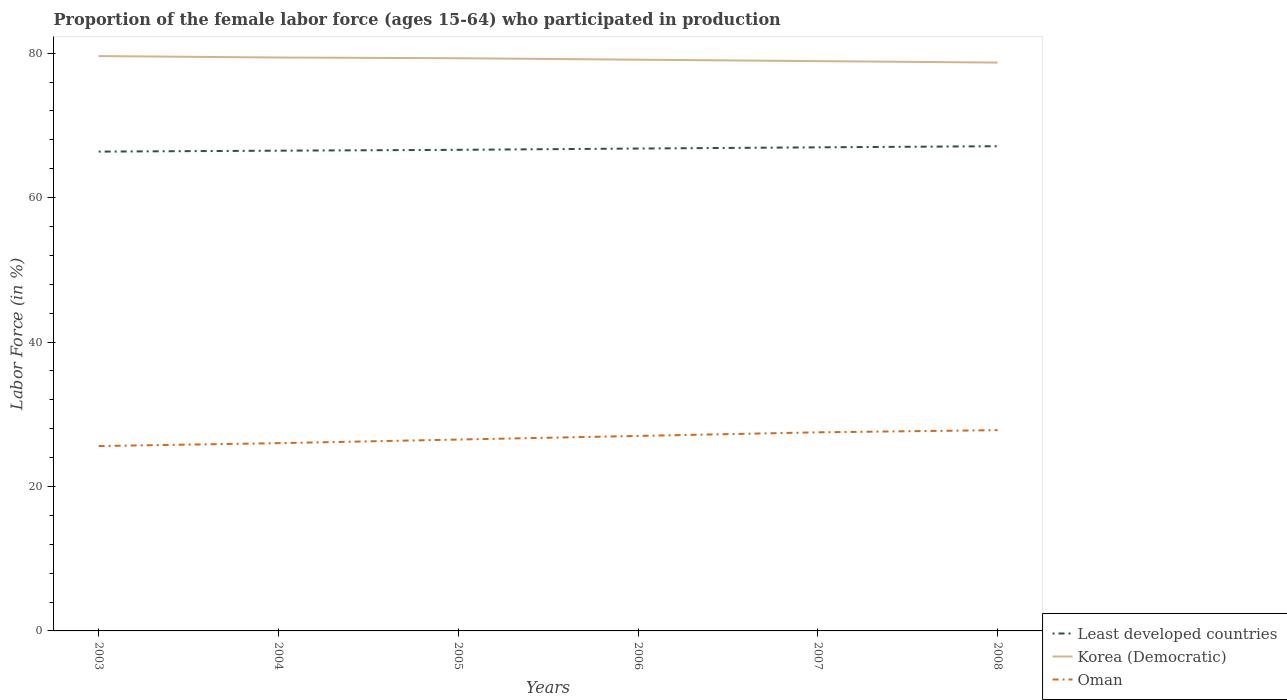How many different coloured lines are there?
Keep it short and to the point. 3. Does the line corresponding to Least developed countries intersect with the line corresponding to Oman?
Your answer should be very brief. No. Across all years, what is the maximum proportion of the female labor force who participated in production in Oman?
Give a very brief answer. 25.6. In which year was the proportion of the female labor force who participated in production in Least developed countries maximum?
Make the answer very short. 2003. What is the total proportion of the female labor force who participated in production in Korea (Democratic) in the graph?
Offer a terse response. 0.3. What is the difference between the highest and the second highest proportion of the female labor force who participated in production in Oman?
Your answer should be compact. 2.2. How many lines are there?
Your answer should be compact. 3. How many years are there in the graph?
Keep it short and to the point. 6. Does the graph contain any zero values?
Give a very brief answer. No. Does the graph contain grids?
Your answer should be very brief. No. What is the title of the graph?
Give a very brief answer. Proportion of the female labor force (ages 15-64) who participated in production. What is the label or title of the X-axis?
Offer a very short reply. Years. What is the label or title of the Y-axis?
Your answer should be very brief. Labor Force (in %). What is the Labor Force (in %) of Least developed countries in 2003?
Make the answer very short. 66.37. What is the Labor Force (in %) of Korea (Democratic) in 2003?
Offer a very short reply. 79.6. What is the Labor Force (in %) in Oman in 2003?
Provide a succinct answer. 25.6. What is the Labor Force (in %) of Least developed countries in 2004?
Your response must be concise. 66.5. What is the Labor Force (in %) of Korea (Democratic) in 2004?
Your response must be concise. 79.4. What is the Labor Force (in %) in Least developed countries in 2005?
Provide a short and direct response. 66.62. What is the Labor Force (in %) in Korea (Democratic) in 2005?
Offer a very short reply. 79.3. What is the Labor Force (in %) of Least developed countries in 2006?
Ensure brevity in your answer.  66.8. What is the Labor Force (in %) in Korea (Democratic) in 2006?
Provide a short and direct response. 79.1. What is the Labor Force (in %) of Least developed countries in 2007?
Provide a short and direct response. 66.96. What is the Labor Force (in %) of Korea (Democratic) in 2007?
Keep it short and to the point. 78.9. What is the Labor Force (in %) of Oman in 2007?
Ensure brevity in your answer.  27.5. What is the Labor Force (in %) of Least developed countries in 2008?
Offer a terse response. 67.12. What is the Labor Force (in %) in Korea (Democratic) in 2008?
Keep it short and to the point. 78.7. What is the Labor Force (in %) in Oman in 2008?
Ensure brevity in your answer.  27.8. Across all years, what is the maximum Labor Force (in %) of Least developed countries?
Offer a terse response. 67.12. Across all years, what is the maximum Labor Force (in %) in Korea (Democratic)?
Ensure brevity in your answer.  79.6. Across all years, what is the maximum Labor Force (in %) of Oman?
Keep it short and to the point. 27.8. Across all years, what is the minimum Labor Force (in %) of Least developed countries?
Provide a succinct answer. 66.37. Across all years, what is the minimum Labor Force (in %) in Korea (Democratic)?
Provide a succinct answer. 78.7. Across all years, what is the minimum Labor Force (in %) of Oman?
Keep it short and to the point. 25.6. What is the total Labor Force (in %) of Least developed countries in the graph?
Provide a succinct answer. 400.37. What is the total Labor Force (in %) in Korea (Democratic) in the graph?
Your answer should be compact. 475. What is the total Labor Force (in %) of Oman in the graph?
Keep it short and to the point. 160.4. What is the difference between the Labor Force (in %) of Least developed countries in 2003 and that in 2004?
Your response must be concise. -0.13. What is the difference between the Labor Force (in %) of Oman in 2003 and that in 2004?
Provide a short and direct response. -0.4. What is the difference between the Labor Force (in %) in Least developed countries in 2003 and that in 2005?
Keep it short and to the point. -0.25. What is the difference between the Labor Force (in %) of Korea (Democratic) in 2003 and that in 2005?
Your answer should be compact. 0.3. What is the difference between the Labor Force (in %) of Least developed countries in 2003 and that in 2006?
Give a very brief answer. -0.43. What is the difference between the Labor Force (in %) in Korea (Democratic) in 2003 and that in 2006?
Provide a succinct answer. 0.5. What is the difference between the Labor Force (in %) of Oman in 2003 and that in 2006?
Your answer should be very brief. -1.4. What is the difference between the Labor Force (in %) in Least developed countries in 2003 and that in 2007?
Provide a succinct answer. -0.59. What is the difference between the Labor Force (in %) of Least developed countries in 2003 and that in 2008?
Ensure brevity in your answer.  -0.75. What is the difference between the Labor Force (in %) of Oman in 2003 and that in 2008?
Provide a succinct answer. -2.2. What is the difference between the Labor Force (in %) in Least developed countries in 2004 and that in 2005?
Ensure brevity in your answer.  -0.12. What is the difference between the Labor Force (in %) of Korea (Democratic) in 2004 and that in 2005?
Keep it short and to the point. 0.1. What is the difference between the Labor Force (in %) in Least developed countries in 2004 and that in 2006?
Provide a short and direct response. -0.3. What is the difference between the Labor Force (in %) of Korea (Democratic) in 2004 and that in 2006?
Make the answer very short. 0.3. What is the difference between the Labor Force (in %) in Least developed countries in 2004 and that in 2007?
Ensure brevity in your answer.  -0.46. What is the difference between the Labor Force (in %) of Oman in 2004 and that in 2007?
Offer a very short reply. -1.5. What is the difference between the Labor Force (in %) of Least developed countries in 2004 and that in 2008?
Give a very brief answer. -0.62. What is the difference between the Labor Force (in %) in Oman in 2004 and that in 2008?
Offer a very short reply. -1.8. What is the difference between the Labor Force (in %) in Least developed countries in 2005 and that in 2006?
Give a very brief answer. -0.18. What is the difference between the Labor Force (in %) of Korea (Democratic) in 2005 and that in 2006?
Offer a terse response. 0.2. What is the difference between the Labor Force (in %) of Least developed countries in 2005 and that in 2007?
Ensure brevity in your answer.  -0.34. What is the difference between the Labor Force (in %) of Korea (Democratic) in 2005 and that in 2007?
Make the answer very short. 0.4. What is the difference between the Labor Force (in %) in Least developed countries in 2005 and that in 2008?
Give a very brief answer. -0.5. What is the difference between the Labor Force (in %) of Korea (Democratic) in 2005 and that in 2008?
Make the answer very short. 0.6. What is the difference between the Labor Force (in %) of Least developed countries in 2006 and that in 2007?
Keep it short and to the point. -0.17. What is the difference between the Labor Force (in %) of Least developed countries in 2006 and that in 2008?
Provide a succinct answer. -0.32. What is the difference between the Labor Force (in %) in Korea (Democratic) in 2006 and that in 2008?
Provide a succinct answer. 0.4. What is the difference between the Labor Force (in %) of Least developed countries in 2007 and that in 2008?
Provide a succinct answer. -0.16. What is the difference between the Labor Force (in %) of Korea (Democratic) in 2007 and that in 2008?
Your response must be concise. 0.2. What is the difference between the Labor Force (in %) of Oman in 2007 and that in 2008?
Offer a terse response. -0.3. What is the difference between the Labor Force (in %) in Least developed countries in 2003 and the Labor Force (in %) in Korea (Democratic) in 2004?
Provide a short and direct response. -13.03. What is the difference between the Labor Force (in %) of Least developed countries in 2003 and the Labor Force (in %) of Oman in 2004?
Ensure brevity in your answer.  40.37. What is the difference between the Labor Force (in %) of Korea (Democratic) in 2003 and the Labor Force (in %) of Oman in 2004?
Keep it short and to the point. 53.6. What is the difference between the Labor Force (in %) of Least developed countries in 2003 and the Labor Force (in %) of Korea (Democratic) in 2005?
Your answer should be very brief. -12.93. What is the difference between the Labor Force (in %) of Least developed countries in 2003 and the Labor Force (in %) of Oman in 2005?
Offer a very short reply. 39.87. What is the difference between the Labor Force (in %) of Korea (Democratic) in 2003 and the Labor Force (in %) of Oman in 2005?
Your answer should be compact. 53.1. What is the difference between the Labor Force (in %) in Least developed countries in 2003 and the Labor Force (in %) in Korea (Democratic) in 2006?
Provide a short and direct response. -12.73. What is the difference between the Labor Force (in %) in Least developed countries in 2003 and the Labor Force (in %) in Oman in 2006?
Your response must be concise. 39.37. What is the difference between the Labor Force (in %) in Korea (Democratic) in 2003 and the Labor Force (in %) in Oman in 2006?
Your response must be concise. 52.6. What is the difference between the Labor Force (in %) in Least developed countries in 2003 and the Labor Force (in %) in Korea (Democratic) in 2007?
Provide a short and direct response. -12.53. What is the difference between the Labor Force (in %) in Least developed countries in 2003 and the Labor Force (in %) in Oman in 2007?
Ensure brevity in your answer.  38.87. What is the difference between the Labor Force (in %) of Korea (Democratic) in 2003 and the Labor Force (in %) of Oman in 2007?
Give a very brief answer. 52.1. What is the difference between the Labor Force (in %) of Least developed countries in 2003 and the Labor Force (in %) of Korea (Democratic) in 2008?
Keep it short and to the point. -12.33. What is the difference between the Labor Force (in %) of Least developed countries in 2003 and the Labor Force (in %) of Oman in 2008?
Your response must be concise. 38.57. What is the difference between the Labor Force (in %) in Korea (Democratic) in 2003 and the Labor Force (in %) in Oman in 2008?
Give a very brief answer. 51.8. What is the difference between the Labor Force (in %) of Least developed countries in 2004 and the Labor Force (in %) of Korea (Democratic) in 2005?
Your response must be concise. -12.8. What is the difference between the Labor Force (in %) in Least developed countries in 2004 and the Labor Force (in %) in Oman in 2005?
Offer a terse response. 40. What is the difference between the Labor Force (in %) in Korea (Democratic) in 2004 and the Labor Force (in %) in Oman in 2005?
Your response must be concise. 52.9. What is the difference between the Labor Force (in %) in Least developed countries in 2004 and the Labor Force (in %) in Korea (Democratic) in 2006?
Your answer should be compact. -12.6. What is the difference between the Labor Force (in %) in Least developed countries in 2004 and the Labor Force (in %) in Oman in 2006?
Provide a short and direct response. 39.5. What is the difference between the Labor Force (in %) in Korea (Democratic) in 2004 and the Labor Force (in %) in Oman in 2006?
Make the answer very short. 52.4. What is the difference between the Labor Force (in %) in Least developed countries in 2004 and the Labor Force (in %) in Korea (Democratic) in 2007?
Your answer should be compact. -12.4. What is the difference between the Labor Force (in %) in Least developed countries in 2004 and the Labor Force (in %) in Oman in 2007?
Your answer should be compact. 39. What is the difference between the Labor Force (in %) of Korea (Democratic) in 2004 and the Labor Force (in %) of Oman in 2007?
Provide a short and direct response. 51.9. What is the difference between the Labor Force (in %) in Least developed countries in 2004 and the Labor Force (in %) in Korea (Democratic) in 2008?
Your response must be concise. -12.2. What is the difference between the Labor Force (in %) in Least developed countries in 2004 and the Labor Force (in %) in Oman in 2008?
Your answer should be compact. 38.7. What is the difference between the Labor Force (in %) in Korea (Democratic) in 2004 and the Labor Force (in %) in Oman in 2008?
Offer a terse response. 51.6. What is the difference between the Labor Force (in %) in Least developed countries in 2005 and the Labor Force (in %) in Korea (Democratic) in 2006?
Offer a terse response. -12.48. What is the difference between the Labor Force (in %) of Least developed countries in 2005 and the Labor Force (in %) of Oman in 2006?
Ensure brevity in your answer.  39.62. What is the difference between the Labor Force (in %) in Korea (Democratic) in 2005 and the Labor Force (in %) in Oman in 2006?
Your answer should be compact. 52.3. What is the difference between the Labor Force (in %) of Least developed countries in 2005 and the Labor Force (in %) of Korea (Democratic) in 2007?
Your answer should be compact. -12.28. What is the difference between the Labor Force (in %) of Least developed countries in 2005 and the Labor Force (in %) of Oman in 2007?
Your response must be concise. 39.12. What is the difference between the Labor Force (in %) in Korea (Democratic) in 2005 and the Labor Force (in %) in Oman in 2007?
Provide a short and direct response. 51.8. What is the difference between the Labor Force (in %) in Least developed countries in 2005 and the Labor Force (in %) in Korea (Democratic) in 2008?
Offer a very short reply. -12.08. What is the difference between the Labor Force (in %) of Least developed countries in 2005 and the Labor Force (in %) of Oman in 2008?
Keep it short and to the point. 38.82. What is the difference between the Labor Force (in %) of Korea (Democratic) in 2005 and the Labor Force (in %) of Oman in 2008?
Provide a succinct answer. 51.5. What is the difference between the Labor Force (in %) of Least developed countries in 2006 and the Labor Force (in %) of Korea (Democratic) in 2007?
Provide a succinct answer. -12.1. What is the difference between the Labor Force (in %) of Least developed countries in 2006 and the Labor Force (in %) of Oman in 2007?
Provide a short and direct response. 39.3. What is the difference between the Labor Force (in %) of Korea (Democratic) in 2006 and the Labor Force (in %) of Oman in 2007?
Offer a very short reply. 51.6. What is the difference between the Labor Force (in %) of Least developed countries in 2006 and the Labor Force (in %) of Korea (Democratic) in 2008?
Offer a very short reply. -11.9. What is the difference between the Labor Force (in %) of Least developed countries in 2006 and the Labor Force (in %) of Oman in 2008?
Make the answer very short. 39. What is the difference between the Labor Force (in %) of Korea (Democratic) in 2006 and the Labor Force (in %) of Oman in 2008?
Offer a very short reply. 51.3. What is the difference between the Labor Force (in %) in Least developed countries in 2007 and the Labor Force (in %) in Korea (Democratic) in 2008?
Make the answer very short. -11.74. What is the difference between the Labor Force (in %) of Least developed countries in 2007 and the Labor Force (in %) of Oman in 2008?
Your answer should be very brief. 39.16. What is the difference between the Labor Force (in %) in Korea (Democratic) in 2007 and the Labor Force (in %) in Oman in 2008?
Offer a terse response. 51.1. What is the average Labor Force (in %) of Least developed countries per year?
Offer a very short reply. 66.73. What is the average Labor Force (in %) of Korea (Democratic) per year?
Your answer should be compact. 79.17. What is the average Labor Force (in %) in Oman per year?
Keep it short and to the point. 26.73. In the year 2003, what is the difference between the Labor Force (in %) in Least developed countries and Labor Force (in %) in Korea (Democratic)?
Make the answer very short. -13.23. In the year 2003, what is the difference between the Labor Force (in %) in Least developed countries and Labor Force (in %) in Oman?
Give a very brief answer. 40.77. In the year 2003, what is the difference between the Labor Force (in %) in Korea (Democratic) and Labor Force (in %) in Oman?
Your response must be concise. 54. In the year 2004, what is the difference between the Labor Force (in %) in Least developed countries and Labor Force (in %) in Korea (Democratic)?
Provide a succinct answer. -12.9. In the year 2004, what is the difference between the Labor Force (in %) of Least developed countries and Labor Force (in %) of Oman?
Offer a terse response. 40.5. In the year 2004, what is the difference between the Labor Force (in %) in Korea (Democratic) and Labor Force (in %) in Oman?
Offer a terse response. 53.4. In the year 2005, what is the difference between the Labor Force (in %) of Least developed countries and Labor Force (in %) of Korea (Democratic)?
Offer a terse response. -12.68. In the year 2005, what is the difference between the Labor Force (in %) in Least developed countries and Labor Force (in %) in Oman?
Keep it short and to the point. 40.12. In the year 2005, what is the difference between the Labor Force (in %) in Korea (Democratic) and Labor Force (in %) in Oman?
Your answer should be compact. 52.8. In the year 2006, what is the difference between the Labor Force (in %) of Least developed countries and Labor Force (in %) of Korea (Democratic)?
Offer a very short reply. -12.3. In the year 2006, what is the difference between the Labor Force (in %) of Least developed countries and Labor Force (in %) of Oman?
Make the answer very short. 39.8. In the year 2006, what is the difference between the Labor Force (in %) in Korea (Democratic) and Labor Force (in %) in Oman?
Your response must be concise. 52.1. In the year 2007, what is the difference between the Labor Force (in %) in Least developed countries and Labor Force (in %) in Korea (Democratic)?
Ensure brevity in your answer.  -11.94. In the year 2007, what is the difference between the Labor Force (in %) in Least developed countries and Labor Force (in %) in Oman?
Offer a terse response. 39.46. In the year 2007, what is the difference between the Labor Force (in %) of Korea (Democratic) and Labor Force (in %) of Oman?
Provide a succinct answer. 51.4. In the year 2008, what is the difference between the Labor Force (in %) of Least developed countries and Labor Force (in %) of Korea (Democratic)?
Give a very brief answer. -11.58. In the year 2008, what is the difference between the Labor Force (in %) in Least developed countries and Labor Force (in %) in Oman?
Offer a terse response. 39.32. In the year 2008, what is the difference between the Labor Force (in %) in Korea (Democratic) and Labor Force (in %) in Oman?
Provide a succinct answer. 50.9. What is the ratio of the Labor Force (in %) in Korea (Democratic) in 2003 to that in 2004?
Make the answer very short. 1. What is the ratio of the Labor Force (in %) in Oman in 2003 to that in 2004?
Make the answer very short. 0.98. What is the ratio of the Labor Force (in %) of Korea (Democratic) in 2003 to that in 2006?
Provide a short and direct response. 1.01. What is the ratio of the Labor Force (in %) of Oman in 2003 to that in 2006?
Give a very brief answer. 0.95. What is the ratio of the Labor Force (in %) in Least developed countries in 2003 to that in 2007?
Your answer should be compact. 0.99. What is the ratio of the Labor Force (in %) of Korea (Democratic) in 2003 to that in 2007?
Give a very brief answer. 1.01. What is the ratio of the Labor Force (in %) in Oman in 2003 to that in 2007?
Provide a succinct answer. 0.93. What is the ratio of the Labor Force (in %) of Least developed countries in 2003 to that in 2008?
Give a very brief answer. 0.99. What is the ratio of the Labor Force (in %) in Korea (Democratic) in 2003 to that in 2008?
Provide a succinct answer. 1.01. What is the ratio of the Labor Force (in %) of Oman in 2003 to that in 2008?
Your response must be concise. 0.92. What is the ratio of the Labor Force (in %) of Least developed countries in 2004 to that in 2005?
Make the answer very short. 1. What is the ratio of the Labor Force (in %) of Korea (Democratic) in 2004 to that in 2005?
Give a very brief answer. 1. What is the ratio of the Labor Force (in %) in Oman in 2004 to that in 2005?
Offer a terse response. 0.98. What is the ratio of the Labor Force (in %) in Korea (Democratic) in 2004 to that in 2006?
Provide a succinct answer. 1. What is the ratio of the Labor Force (in %) of Oman in 2004 to that in 2006?
Give a very brief answer. 0.96. What is the ratio of the Labor Force (in %) in Korea (Democratic) in 2004 to that in 2007?
Ensure brevity in your answer.  1.01. What is the ratio of the Labor Force (in %) of Oman in 2004 to that in 2007?
Offer a terse response. 0.95. What is the ratio of the Labor Force (in %) in Korea (Democratic) in 2004 to that in 2008?
Give a very brief answer. 1.01. What is the ratio of the Labor Force (in %) of Oman in 2004 to that in 2008?
Your answer should be compact. 0.94. What is the ratio of the Labor Force (in %) of Oman in 2005 to that in 2006?
Your answer should be compact. 0.98. What is the ratio of the Labor Force (in %) of Least developed countries in 2005 to that in 2007?
Your answer should be compact. 0.99. What is the ratio of the Labor Force (in %) of Oman in 2005 to that in 2007?
Your response must be concise. 0.96. What is the ratio of the Labor Force (in %) of Korea (Democratic) in 2005 to that in 2008?
Provide a short and direct response. 1.01. What is the ratio of the Labor Force (in %) in Oman in 2005 to that in 2008?
Your answer should be very brief. 0.95. What is the ratio of the Labor Force (in %) in Korea (Democratic) in 2006 to that in 2007?
Ensure brevity in your answer.  1. What is the ratio of the Labor Force (in %) of Oman in 2006 to that in 2007?
Keep it short and to the point. 0.98. What is the ratio of the Labor Force (in %) in Oman in 2006 to that in 2008?
Your answer should be compact. 0.97. What is the ratio of the Labor Force (in %) in Korea (Democratic) in 2007 to that in 2008?
Your answer should be compact. 1. What is the difference between the highest and the second highest Labor Force (in %) in Least developed countries?
Ensure brevity in your answer.  0.16. What is the difference between the highest and the lowest Labor Force (in %) of Least developed countries?
Keep it short and to the point. 0.75. What is the difference between the highest and the lowest Labor Force (in %) of Oman?
Provide a short and direct response. 2.2. 